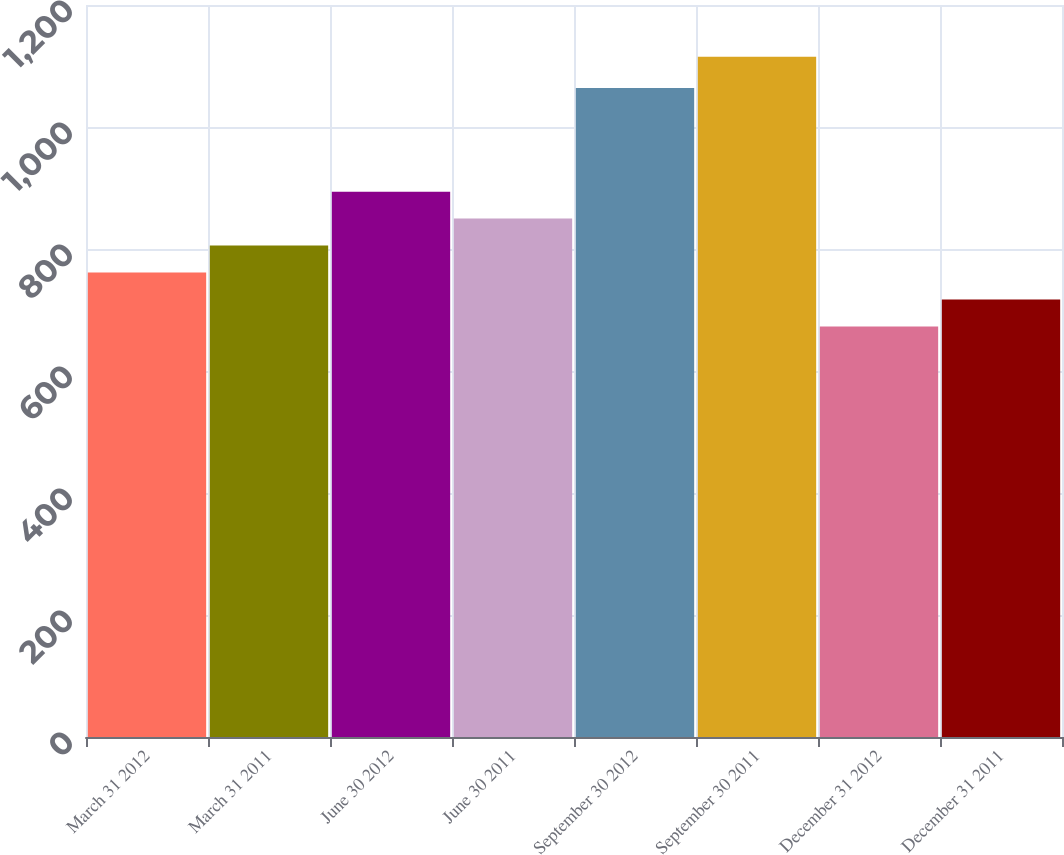Convert chart. <chart><loc_0><loc_0><loc_500><loc_500><bar_chart><fcel>March 31 2012<fcel>March 31 2011<fcel>June 30 2012<fcel>June 30 2011<fcel>September 30 2012<fcel>September 30 2011<fcel>December 31 2012<fcel>December 31 2011<nl><fcel>761.4<fcel>805.6<fcel>894<fcel>849.8<fcel>1064<fcel>1115<fcel>673<fcel>717.2<nl></chart> 